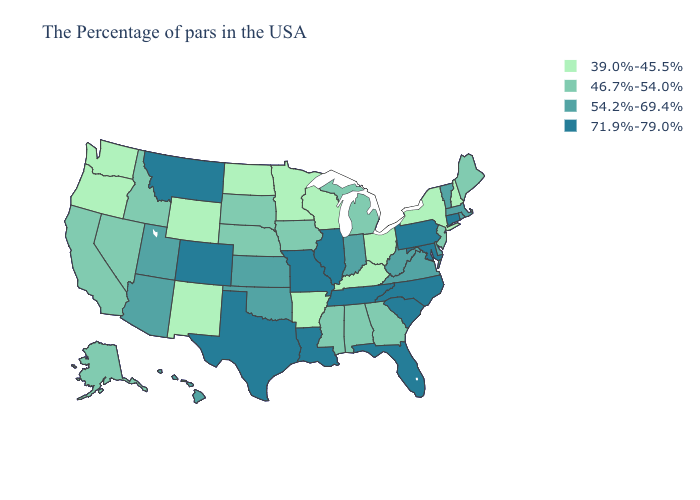Which states have the highest value in the USA?
Quick response, please. Connecticut, Maryland, Pennsylvania, North Carolina, South Carolina, Florida, Tennessee, Illinois, Louisiana, Missouri, Texas, Colorado, Montana. Name the states that have a value in the range 46.7%-54.0%?
Quick response, please. Maine, New Jersey, Georgia, Michigan, Alabama, Mississippi, Iowa, Nebraska, South Dakota, Idaho, Nevada, California, Alaska. What is the lowest value in the Northeast?
Give a very brief answer. 39.0%-45.5%. Name the states that have a value in the range 46.7%-54.0%?
Quick response, please. Maine, New Jersey, Georgia, Michigan, Alabama, Mississippi, Iowa, Nebraska, South Dakota, Idaho, Nevada, California, Alaska. Name the states that have a value in the range 54.2%-69.4%?
Short answer required. Massachusetts, Rhode Island, Vermont, Delaware, Virginia, West Virginia, Indiana, Kansas, Oklahoma, Utah, Arizona, Hawaii. What is the value of South Carolina?
Quick response, please. 71.9%-79.0%. Does Delaware have the same value as Arizona?
Write a very short answer. Yes. What is the highest value in the USA?
Short answer required. 71.9%-79.0%. Name the states that have a value in the range 71.9%-79.0%?
Quick response, please. Connecticut, Maryland, Pennsylvania, North Carolina, South Carolina, Florida, Tennessee, Illinois, Louisiana, Missouri, Texas, Colorado, Montana. Name the states that have a value in the range 54.2%-69.4%?
Give a very brief answer. Massachusetts, Rhode Island, Vermont, Delaware, Virginia, West Virginia, Indiana, Kansas, Oklahoma, Utah, Arizona, Hawaii. Does the map have missing data?
Be succinct. No. What is the value of Louisiana?
Concise answer only. 71.9%-79.0%. Name the states that have a value in the range 54.2%-69.4%?
Quick response, please. Massachusetts, Rhode Island, Vermont, Delaware, Virginia, West Virginia, Indiana, Kansas, Oklahoma, Utah, Arizona, Hawaii. Does the first symbol in the legend represent the smallest category?
Keep it brief. Yes. What is the lowest value in states that border Ohio?
Be succinct. 39.0%-45.5%. 